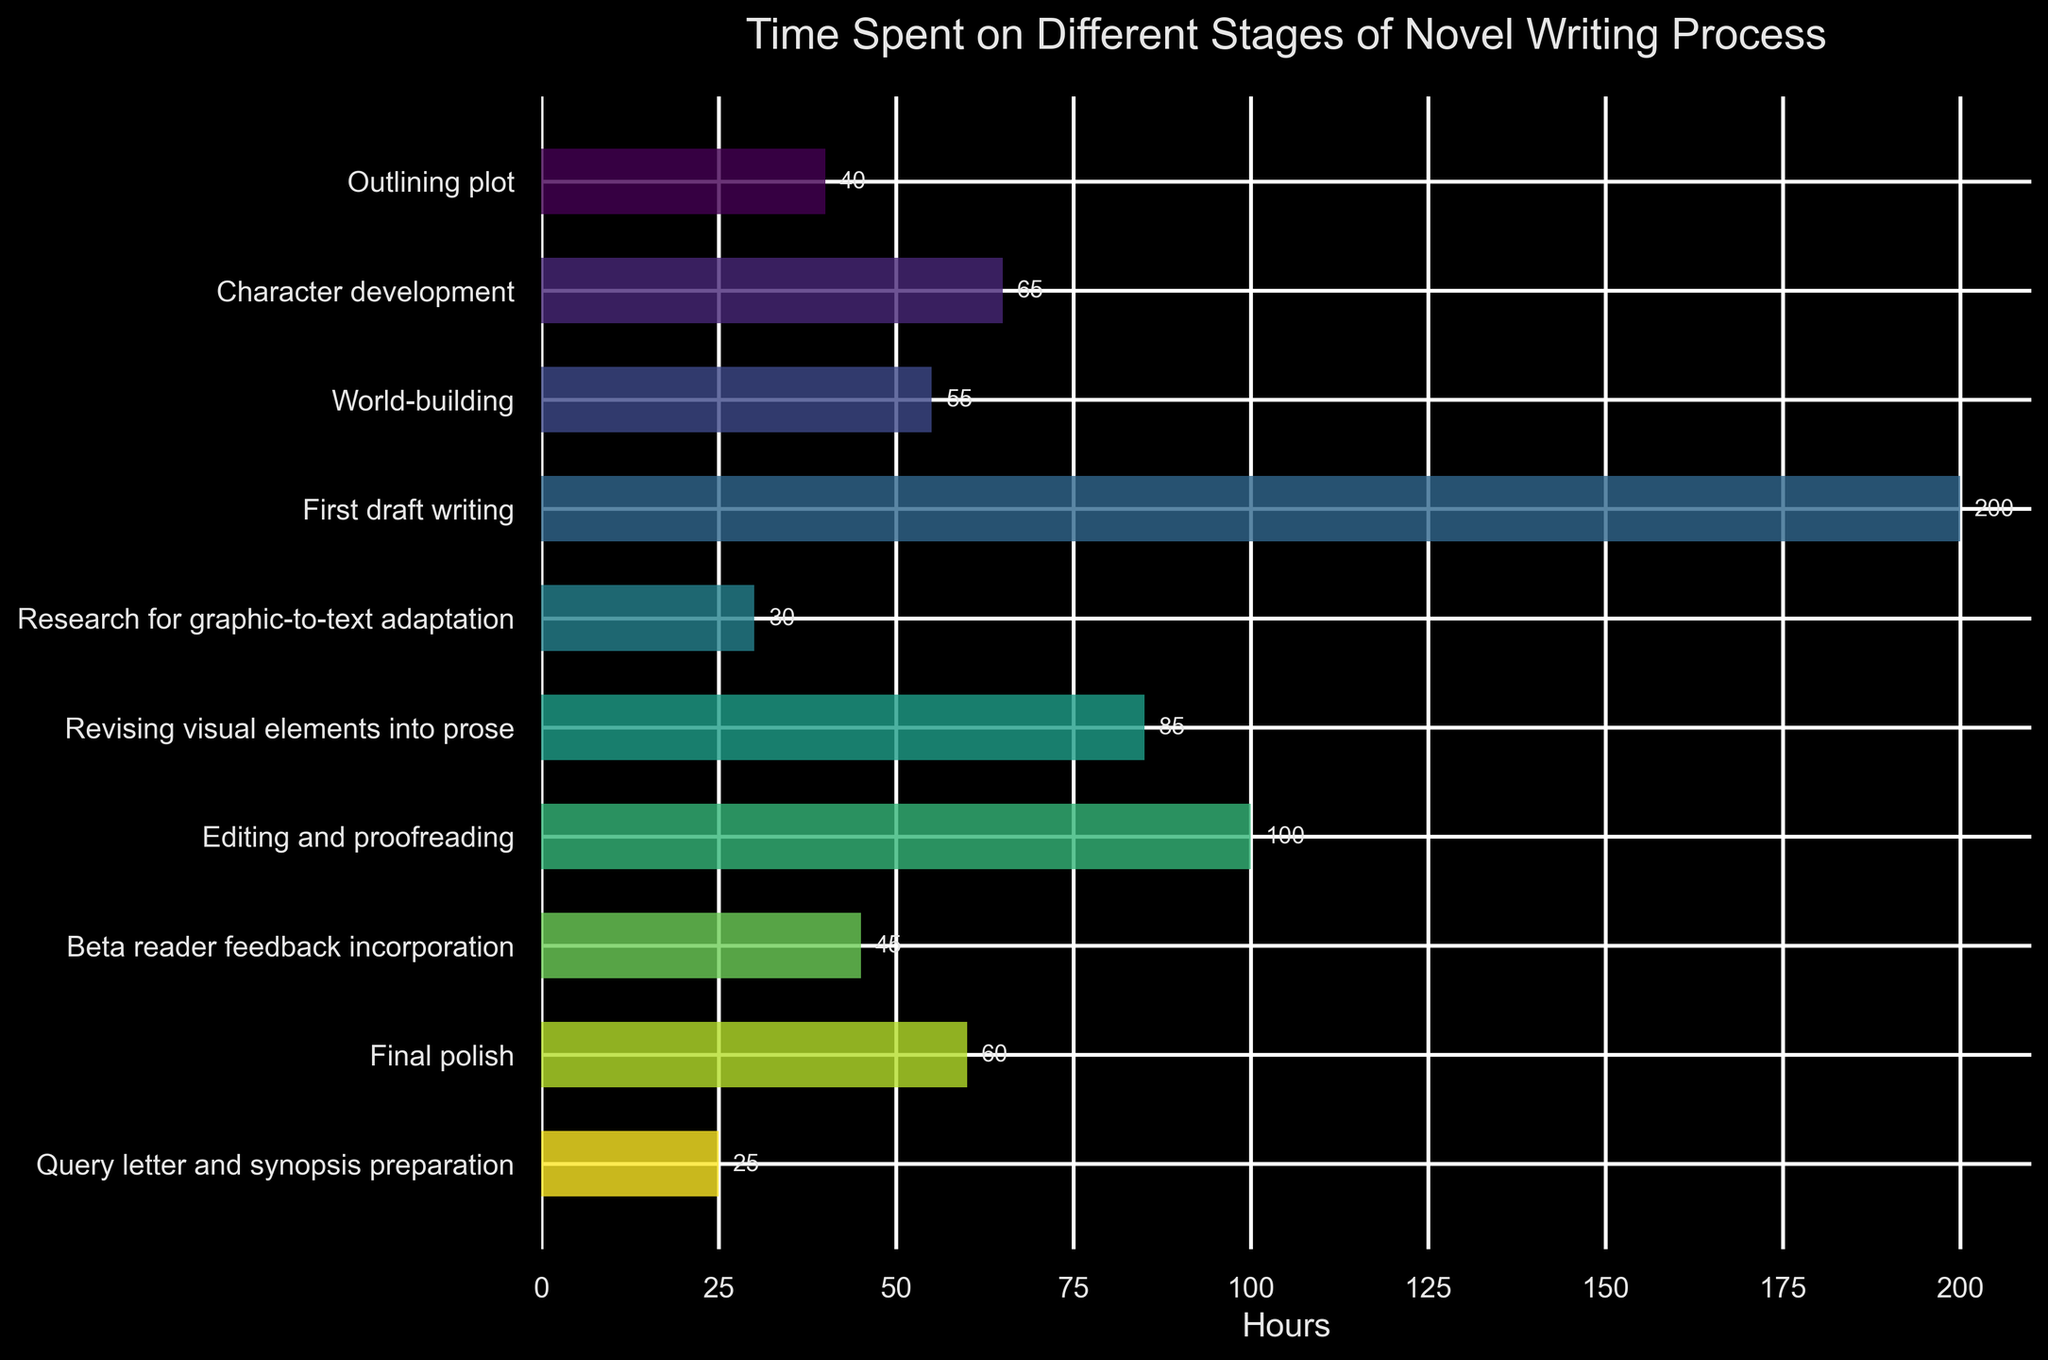What stage consumes the most time in the novel writing process? Looking at the chart, the bar representing "First draft writing" is the longest, indicating the highest time spent.
Answer: First draft writing How much more time is spent on "Editing and proofreading" compared to "Final polish"? The bar for "Editing and proofreading" shows 100 hours, while "Final polish" shows 60 hours. The difference is 100 - 60.
Answer: 40 hours Which stages involve more than 50 hours of work? The bars for "Character development", "World-building", "First draft writing", "Revising visual elements into prose", "Editing and proofreading", and "Final polish" exceed 50 hours.
Answer: Character development, World-building, First draft writing, Revising visual elements into prose, Editing and proofreading, Final polish How many hours are spent combined on "Outlining plot" and "Beta reader feedback incorporation"? The time spent on "Outlining plot" is 40 hours, and "Beta reader feedback incorporation" is 45 hours. Combining these results in 40 + 45.
Answer: 85 hours What is the average time spent across all stages? Add the hours for all stages (40 + 65 + 55 + 200 + 30 + 85 + 100 + 45 + 60 + 25), then divide by the number of stages, which is 10. The total is 705 hours, so the average is 705 / 10.
Answer: 70.5 hours Which stage has the shortest bar and how many hours does it represent? The shortest bar is for "Query letter and synopsis preparation", representing 25 hours.
Answer: Query letter and synopsis preparation, 25 hours Is more time spent revising visual elements into prose or world-building? The bar for "Revising visual elements into prose" shows 85 hours, while "World-building" shows 55 hours. Hence, more time is spent on revising visual elements into prose.
Answer: Revising visual elements into prose What is the total time spent on stages directly related to text adaptation (Sum of "Research for graphic-to-text adaptation" and "Revising visual elements into prose")? The time for "Research for graphic-to-text adaptation" is 30 hours, and for "Revising visual elements into prose" is 85 hours. Adding these gives 30 + 85.
Answer: 115 hours Which stage(s) have a visual appearance of light green? As the bar colors span a gradient, the stage "Character development" appears to have a light green hue.
Answer: Character development 